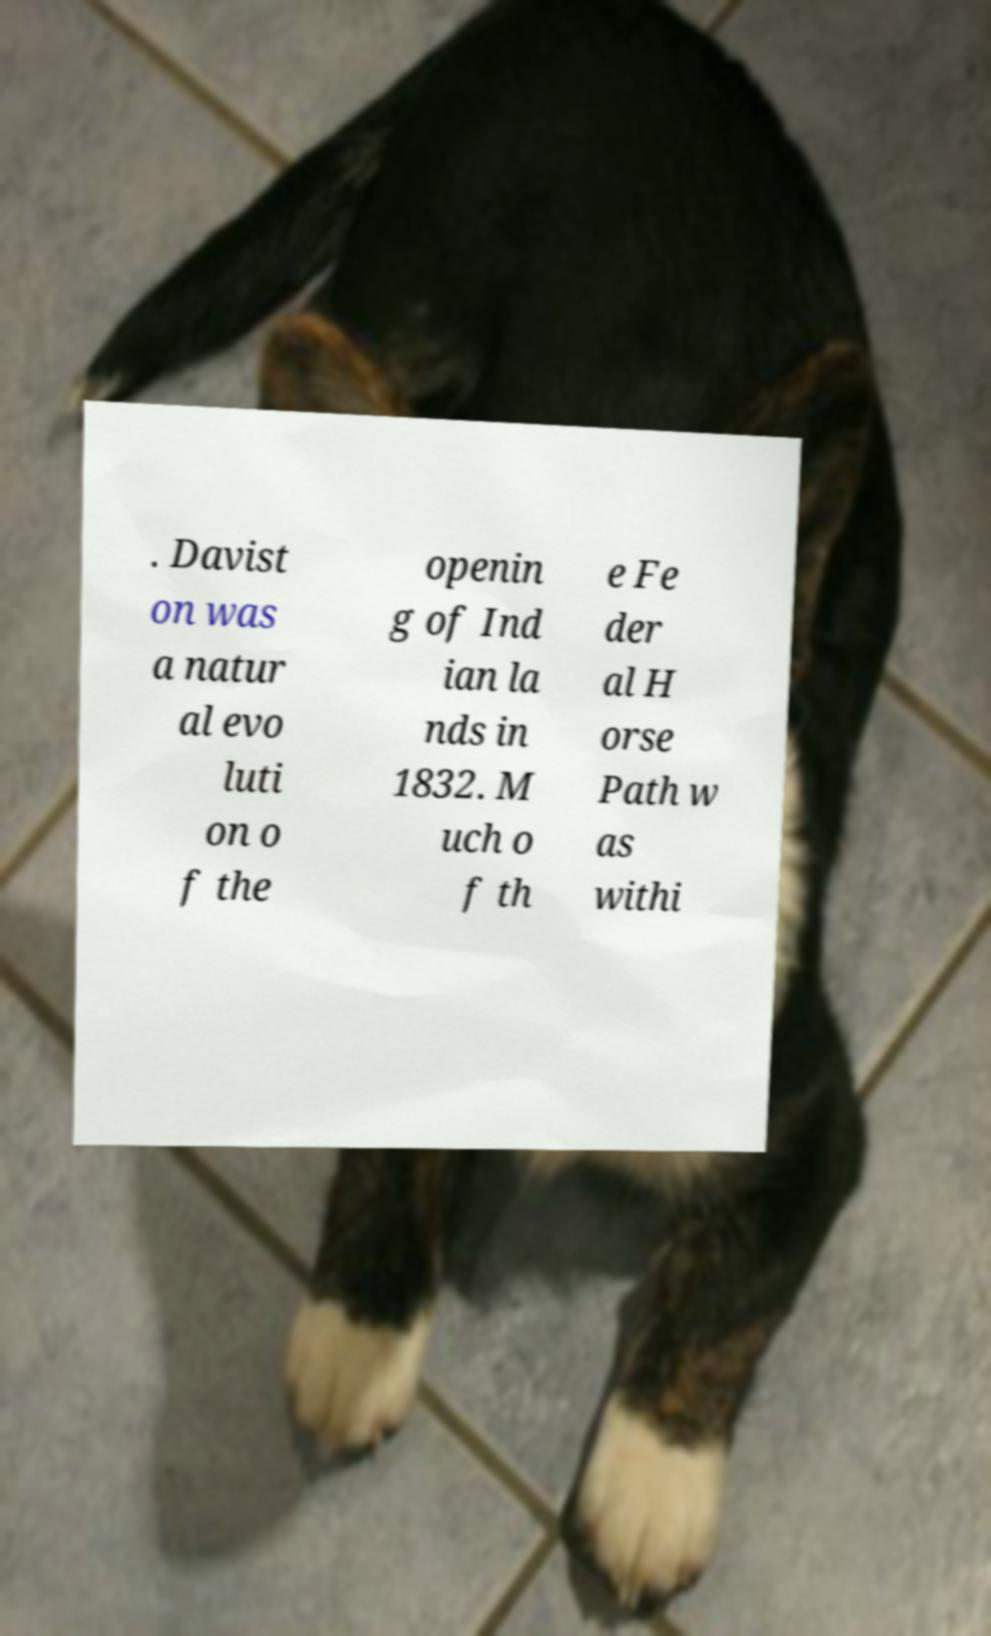Could you extract and type out the text from this image? . Davist on was a natur al evo luti on o f the openin g of Ind ian la nds in 1832. M uch o f th e Fe der al H orse Path w as withi 